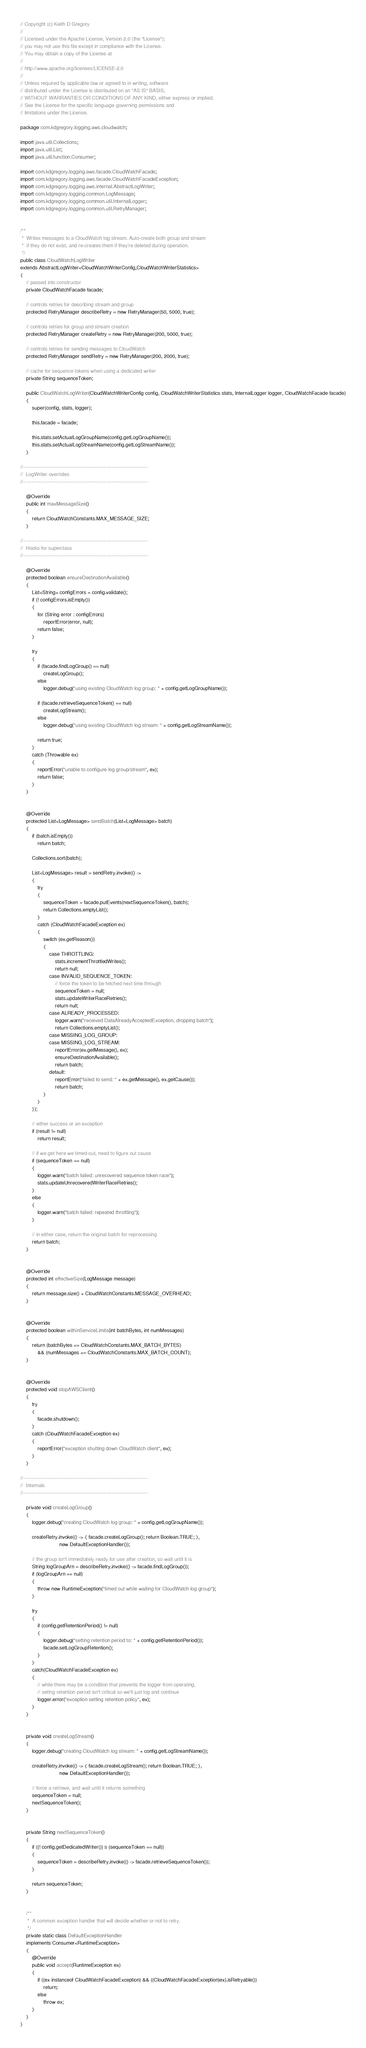Convert code to text. <code><loc_0><loc_0><loc_500><loc_500><_Java_>// Copyright (c) Keith D Gregory
//
// Licensed under the Apache License, Version 2.0 (the "License");
// you may not use this file except in compliance with the License.
// You may obtain a copy of the License at
//
// http://www.apache.org/licenses/LICENSE-2.0
//
// Unless required by applicable law or agreed to in writing, software
// distributed under the License is distributed on an "AS IS" BASIS,
// WITHOUT WARRANTIES OR CONDITIONS OF ANY KIND, either express or implied.
// See the License for the specific language governing permissions and
// limitations under the License.

package com.kdgregory.logging.aws.cloudwatch;

import java.util.Collections;
import java.util.List;
import java.util.function.Consumer;

import com.kdgregory.logging.aws.facade.CloudWatchFacade;
import com.kdgregory.logging.aws.facade.CloudWatchFacadeException;
import com.kdgregory.logging.aws.internal.AbstractLogWriter;
import com.kdgregory.logging.common.LogMessage;
import com.kdgregory.logging.common.util.InternalLogger;
import com.kdgregory.logging.common.util.RetryManager;


/**
 *  Writes messages to a CloudWatch log stream. Auto-create both group and stream
 *  if they do not exist, and re-creates them if they're deleted during operation.
 */
public class CloudWatchLogWriter
extends AbstractLogWriter<CloudWatchWriterConfig,CloudWatchWriterStatistics>
{
    // passed into constructor
    private CloudWatchFacade facade;

    // controls retries for describing stream and group
    protected RetryManager describeRetry = new RetryManager(50, 5000, true);

    // controls retries for group and stream creation
    protected RetryManager createRetry = new RetryManager(200, 5000, true);

    // controls retries for sending messages to CloudWatch
    protected RetryManager sendRetry = new RetryManager(200, 2000, true);

    // cache for sequence tokens when using a dedicated writer
    private String sequenceToken;

    public CloudWatchLogWriter(CloudWatchWriterConfig config, CloudWatchWriterStatistics stats, InternalLogger logger, CloudWatchFacade facade)
    {
        super(config, stats, logger);

        this.facade = facade;

        this.stats.setActualLogGroupName(config.getLogGroupName());
        this.stats.setActualLogStreamName(config.getLogStreamName());
    }

//----------------------------------------------------------------------------
//  LogWriter overrides
//----------------------------------------------------------------------------

    @Override
    public int maxMessageSize()
    {
        return CloudWatchConstants.MAX_MESSAGE_SIZE;
    }

//----------------------------------------------------------------------------
//  Hooks for superclass
//----------------------------------------------------------------------------

    @Override
    protected boolean ensureDestinationAvailable()
    {
        List<String> configErrors = config.validate();
        if (! configErrors.isEmpty())
        {
            for (String error : configErrors)
                reportError(error, null);
            return false;
        }

        try
        {
            if (facade.findLogGroup() == null)
                createLogGroup();
            else
                logger.debug("using existing CloudWatch log group: " + config.getLogGroupName());

            if (facade.retrieveSequenceToken() == null)
                createLogStream();
            else
                logger.debug("using existing CloudWatch log stream: " + config.getLogStreamName());

            return true;
        }
        catch (Throwable ex)
        {
            reportError("unable to configure log group/stream", ex);
            return false;
        }
    }


    @Override
    protected List<LogMessage> sendBatch(List<LogMessage> batch)
    {
        if (batch.isEmpty())
            return batch;

        Collections.sort(batch);

        List<LogMessage> result = sendRetry.invoke(() ->
        {
            try
            {
                sequenceToken = facade.putEvents(nextSequenceToken(), batch);
                return Collections.emptyList();
            }
            catch (CloudWatchFacadeException ex)
            {
                switch (ex.getReason())
                {
                    case THROTTLING:
                        stats.incrementThrottledWrites();
                        return null;
                    case INVALID_SEQUENCE_TOKEN:
                        // force the token to be fetched next time through
                        sequenceToken = null;
                        stats.updateWriterRaceRetries();
                        return null;
                    case ALREADY_PROCESSED:
                        logger.warn("received DataAlreadyAcceptedException, dropping batch");
                        return Collections.emptyList();
                    case MISSING_LOG_GROUP:
                    case MISSING_LOG_STREAM:
                        reportError(ex.getMessage(), ex);
                        ensureDestinationAvailable();
                        return batch;
                    default:
                        reportError("failed to send: " + ex.getMessage(), ex.getCause());
                        return batch;
                }
            }
        });

        // either success or an exception
        if (result != null)
            return result;

        // if we get here we timed-out, need to figure out cause
        if (sequenceToken == null)
        {
            logger.warn("batch failed: unrecovered sequence token race");
            stats.updateUnrecoveredWriterRaceRetries();
        }
        else
        {
            logger.warn("batch failed: repeated throttling");
        }

        // in either case, return the original batch for reprocessing
        return batch;
    }


    @Override
    protected int effectiveSize(LogMessage message)
    {
        return message.size() + CloudWatchConstants.MESSAGE_OVERHEAD;
    }


    @Override
    protected boolean withinServiceLimits(int batchBytes, int numMessages)
    {
        return (batchBytes <= CloudWatchConstants.MAX_BATCH_BYTES)
            && (numMessages <= CloudWatchConstants.MAX_BATCH_COUNT);
    }


    @Override
    protected void stopAWSClient()
    {
        try
        {
            facade.shutdown();
        }
        catch (CloudWatchFacadeException ex)
        {
            reportError("exception shutting down CloudWatch client", ex);
        }
    }

//----------------------------------------------------------------------------
//  Internals
//----------------------------------------------------------------------------

    private void createLogGroup()
    {
        logger.debug("creating CloudWatch log group: " + config.getLogGroupName());

        createRetry.invoke(() -> { facade.createLogGroup(); return Boolean.TRUE; },
                           new DefaultExceptionHandler());

        // the group isn't immediately ready for use after creation, so wait until it is
        String logGroupArn = describeRetry.invoke(() -> facade.findLogGroup());
        if (logGroupArn == null)
        {
            throw new RuntimeException("timed out while waiting for CloudWatch log group");
        }

        try
        {
            if (config.getRetentionPeriod() != null)
            {
                logger.debug("setting retention period to: " + config.getRetentionPeriod());
                facade.setLogGroupRetention();
            }
        }
        catch(CloudWatchFacadeException ex)
        {
            // while there may be a condition that prevents the logger from operating,
            // settng retention period isn't critical so we'll just log and continue
            logger.error("exception setting retention policy", ex);
        }
    }


    private void createLogStream()
    {
        logger.debug("creating CloudWatch log stream: " + config.getLogStreamName());

        createRetry.invoke(() -> { facade.createLogStream(); return Boolean.TRUE; },
                           new DefaultExceptionHandler());

        // force a retrieve, and wait until it returns something
        sequenceToken = null;
        nextSequenceToken();
    }


    private String nextSequenceToken()
    {
        if ((! config.getDedicatedWriter()) || (sequenceToken == null))
        {
            sequenceToken = describeRetry.invoke(() -> facade.retrieveSequenceToken());
        }

        return sequenceToken;
    }


    /**
     *  A common exception handler that will decide whether or not to retry.
     */
    private static class DefaultExceptionHandler
    implements Consumer<RuntimeException>
    {
        @Override
        public void accept(RuntimeException ex)
        {
            if ((ex instanceof CloudWatchFacadeException) && ((CloudWatchFacadeException)ex).isRetryable())
                return;
            else
                throw ex;
        }
    }
}
</code> 